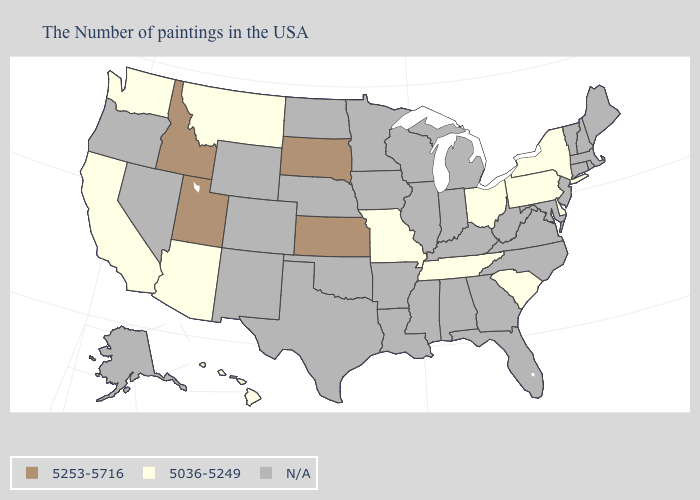Does Kansas have the highest value in the USA?
Be succinct. Yes. Which states have the lowest value in the MidWest?
Keep it brief. Ohio, Missouri. Name the states that have a value in the range N/A?
Give a very brief answer. Maine, Massachusetts, Rhode Island, New Hampshire, Vermont, Connecticut, New Jersey, Maryland, Virginia, North Carolina, West Virginia, Florida, Georgia, Michigan, Kentucky, Indiana, Alabama, Wisconsin, Illinois, Mississippi, Louisiana, Arkansas, Minnesota, Iowa, Nebraska, Oklahoma, Texas, North Dakota, Wyoming, Colorado, New Mexico, Nevada, Oregon, Alaska. What is the value of Texas?
Concise answer only. N/A. What is the value of Illinois?
Quick response, please. N/A. What is the lowest value in the West?
Quick response, please. 5036-5249. What is the value of Georgia?
Write a very short answer. N/A. Among the states that border North Carolina , which have the highest value?
Short answer required. South Carolina, Tennessee. Does Pennsylvania have the highest value in the USA?
Keep it brief. No. What is the lowest value in states that border New York?
Answer briefly. 5036-5249. What is the value of Oklahoma?
Give a very brief answer. N/A. Does the map have missing data?
Answer briefly. Yes. Name the states that have a value in the range 5253-5716?
Answer briefly. Kansas, South Dakota, Utah, Idaho. Does Missouri have the highest value in the USA?
Keep it brief. No. 